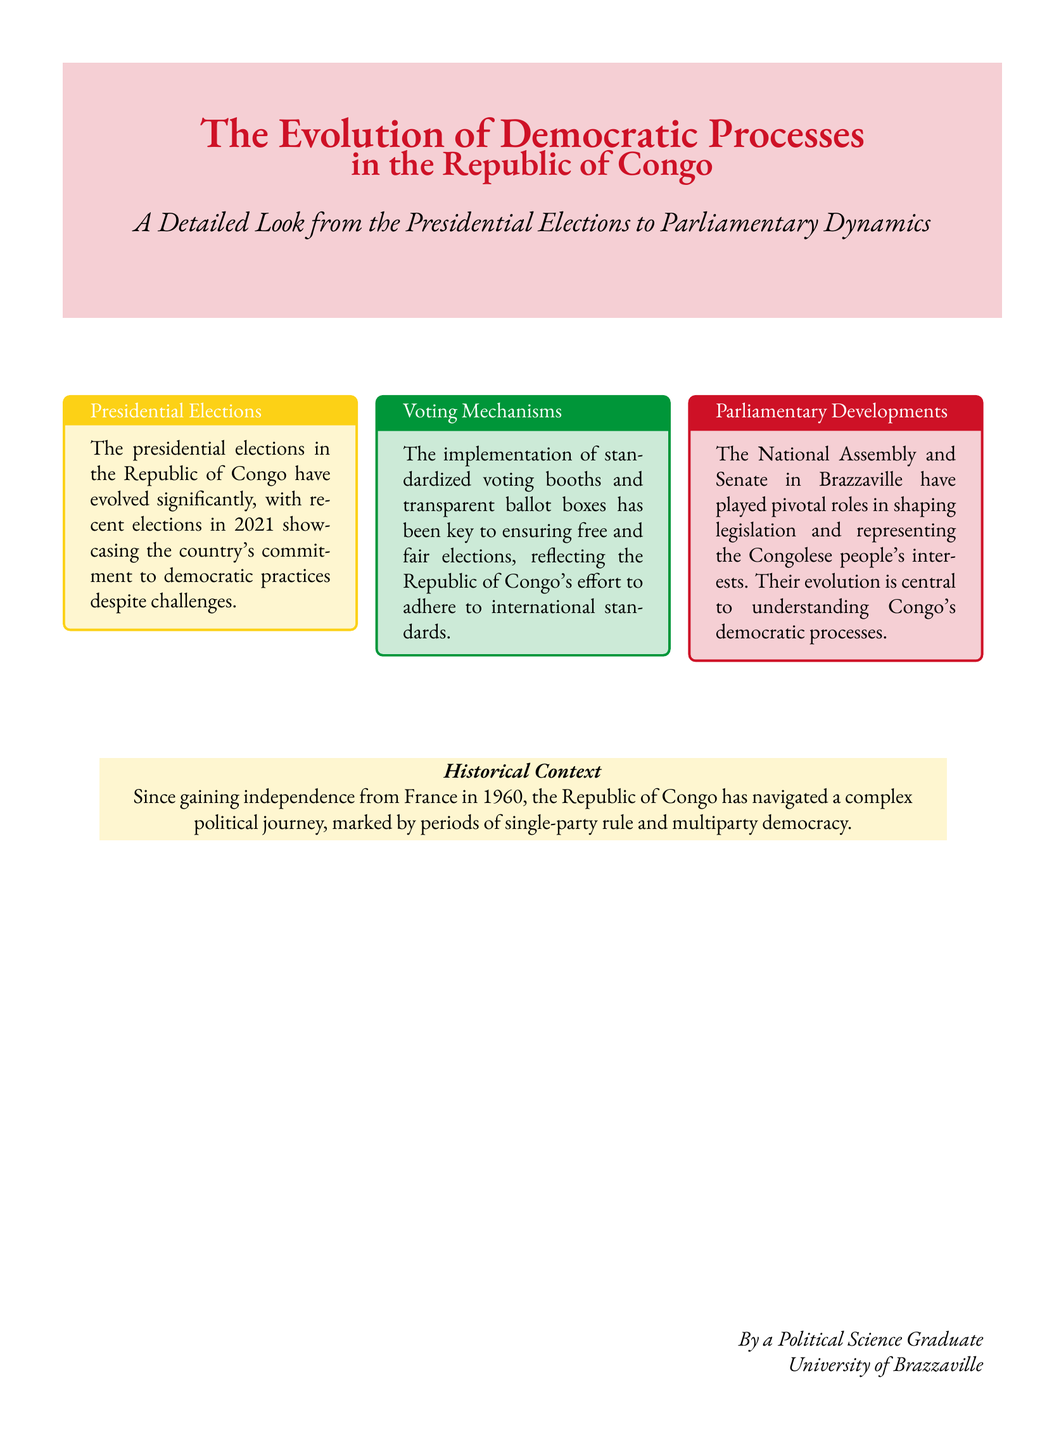What is the title of the book? The title is prominently displayed in large font on the cover.
Answer: The Evolution of Democratic Processes Who wrote the book? The author is credited at the bottom of the cover.
Answer: By a Political Science Graduate What year showcased the recent presidential elections? The document mentions the specific year of the elections.
Answer: 2021 What color is associated with the voting mechanisms section? The box's background color indicates the focus area.
Answer: Green What historical event is marked as the start of Congo's political journey? The historical context mentions a significant date of independence.
Answer: 1960 What key aspect is highlighted in the presidential elections section? The text elaborates on an important factor regarding elections.
Answer: Democratic practices In which city are the National Assembly and Senate located? The document specifies the city's name related to the parliamentary developments.
Answer: Brazzaville What color represents the parliamentary developments section? The color used for that section is relevant to the document's design.
Answer: Red What is emphasized about the voting booths? The voting mechanism description highlights an important feature.
Answer: Standardized 